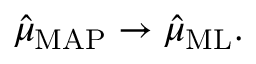<formula> <loc_0><loc_0><loc_500><loc_500>{ \hat { \mu } } _ { M A P } \to { \hat { \mu } } _ { M L } .</formula> 